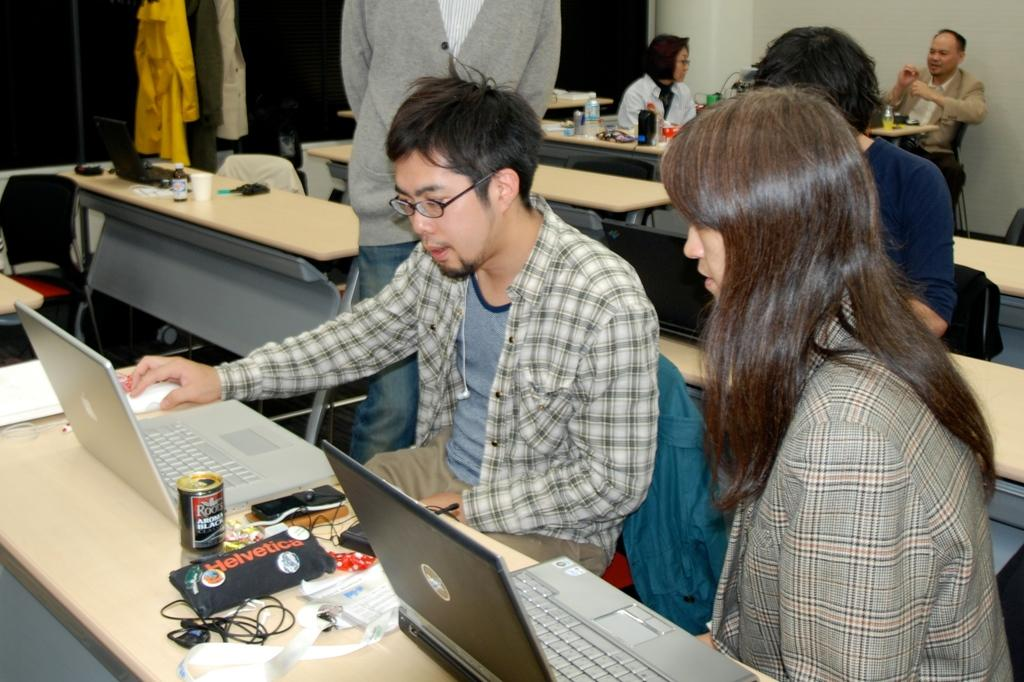What are the people in the image doing? The people in the image are sitting and standing. What type of furniture is present in the image? There are tables and chairs in the image. What electronic devices can be seen on the table? There are laptops on a table in the image. What else is visible on the table? There is a wire visible on the table. What type of comb can be seen in the image? There is no comb present in the image. What type of mist is visible in the image? There is no mist visible in the image. 